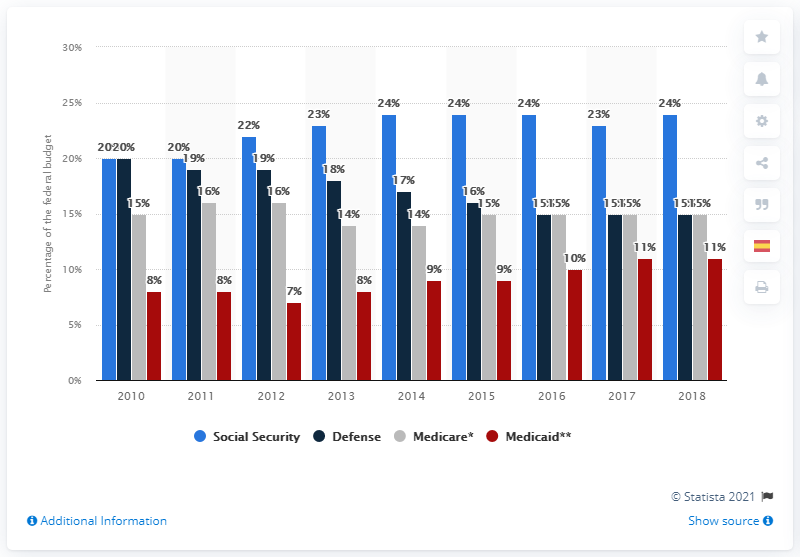Point out several critical features in this image. According to recent estimates, approximately 15% of the United States defense budget is allocated towards Medicare. 